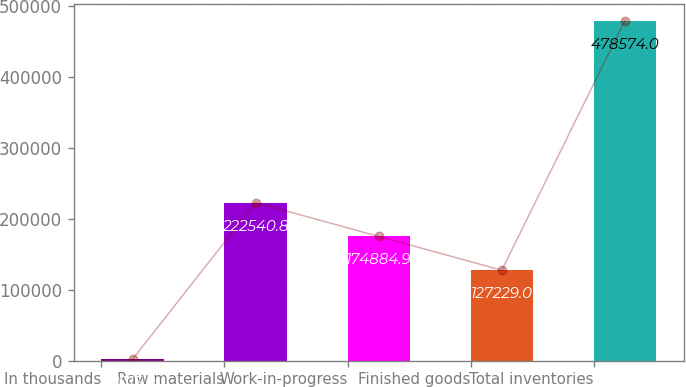Convert chart. <chart><loc_0><loc_0><loc_500><loc_500><bar_chart><fcel>In thousands<fcel>Raw materials<fcel>Work-in-progress<fcel>Finished goods<fcel>Total inventories<nl><fcel>2015<fcel>222541<fcel>174885<fcel>127229<fcel>478574<nl></chart> 